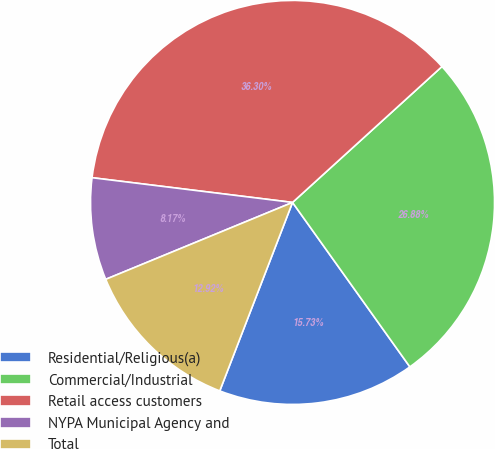Convert chart to OTSL. <chart><loc_0><loc_0><loc_500><loc_500><pie_chart><fcel>Residential/Religious(a)<fcel>Commercial/Industrial<fcel>Retail access customers<fcel>NYPA Municipal Agency and<fcel>Total<nl><fcel>15.73%<fcel>26.88%<fcel>36.3%<fcel>8.17%<fcel>12.92%<nl></chart> 